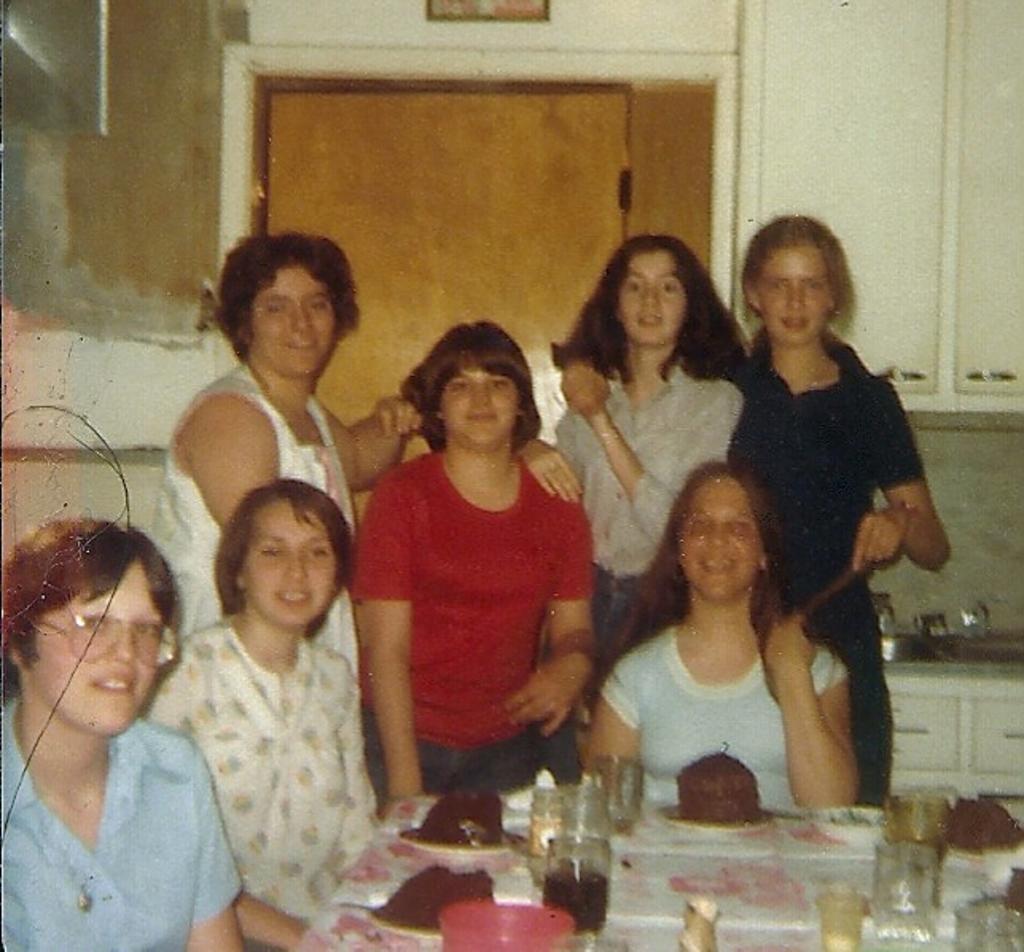Please provide a concise description of this image. In this picture I can see there are few people standing and few of them are sitting in the chairs and there is a table in front of them, there is cake served in the plates and there are water glasses. In the backdrop there is a door and a wall. 